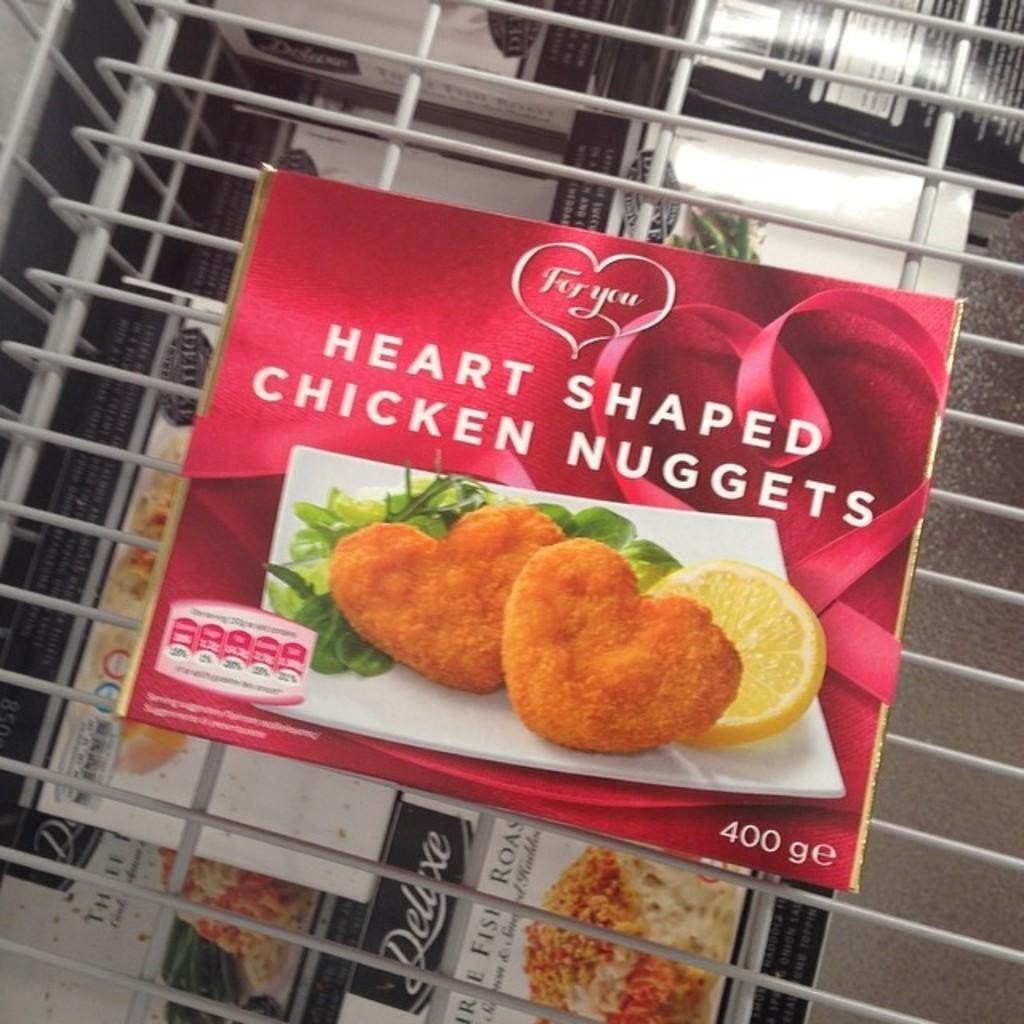What objects are present in the image? There are boxes in the image. What can be found on the boxes? The boxes have text on them. What type of structure is visible in the image? There is a metal grill in the image. What type of birds can be seen arguing on the side of the boxes in the image? There are no birds present in the image, nor is there any indication of an argument. 